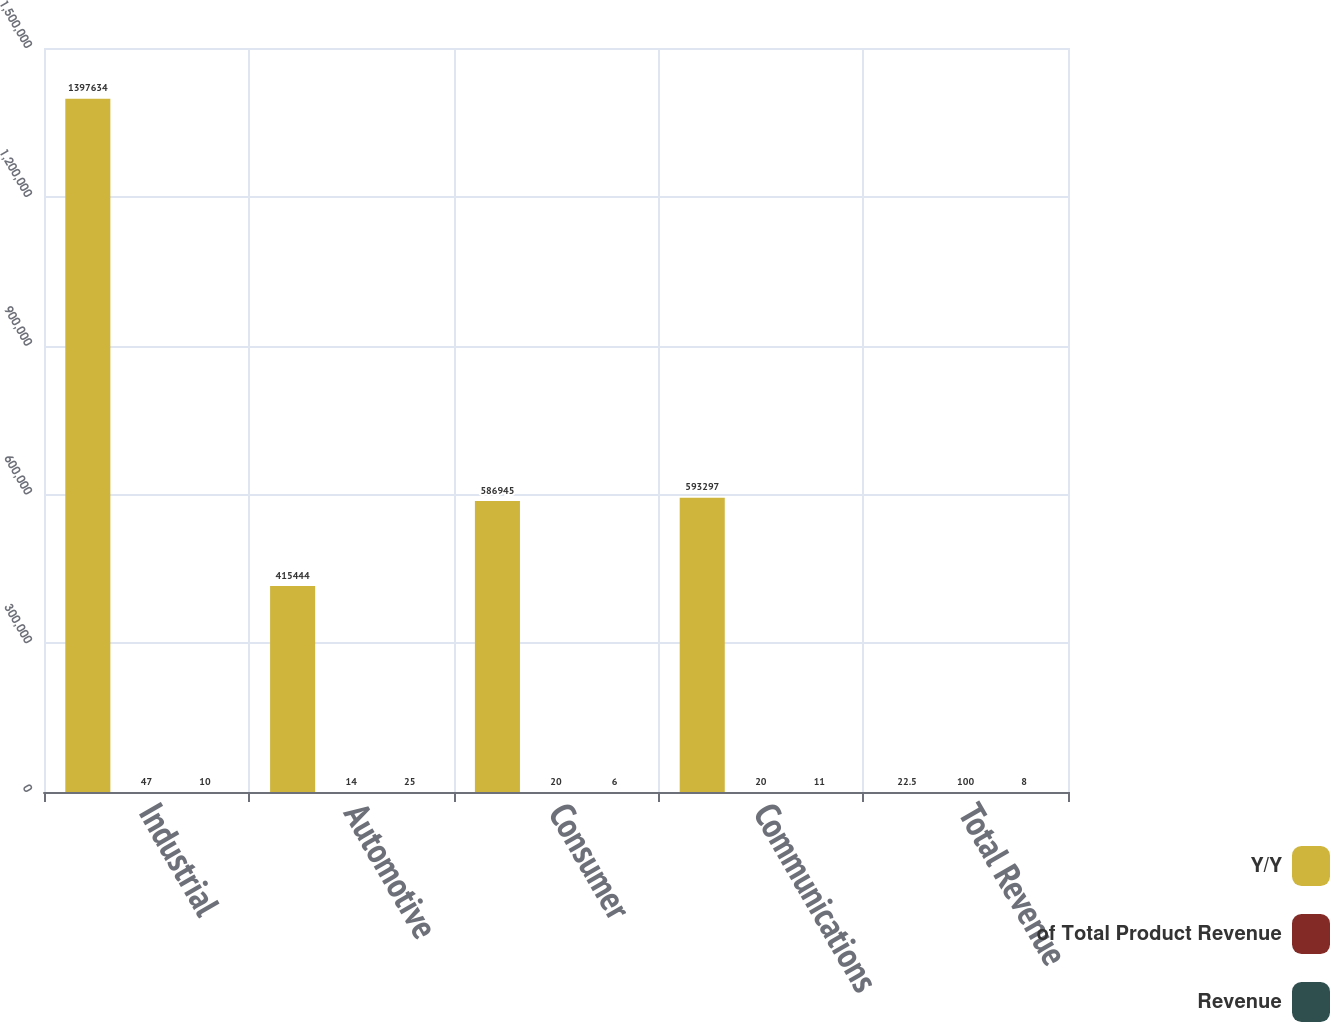Convert chart. <chart><loc_0><loc_0><loc_500><loc_500><stacked_bar_chart><ecel><fcel>Industrial<fcel>Automotive<fcel>Consumer<fcel>Communications<fcel>Total Revenue<nl><fcel>Y/Y<fcel>1.39763e+06<fcel>415444<fcel>586945<fcel>593297<fcel>22.5<nl><fcel>of Total Product Revenue<fcel>47<fcel>14<fcel>20<fcel>20<fcel>100<nl><fcel>Revenue<fcel>10<fcel>25<fcel>6<fcel>11<fcel>8<nl></chart> 